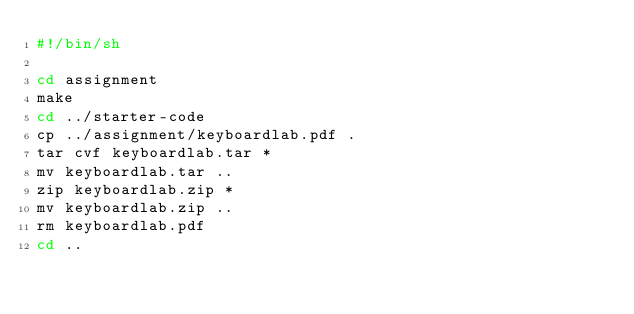Convert code to text. <code><loc_0><loc_0><loc_500><loc_500><_Bash_>#!/bin/sh

cd assignment
make
cd ../starter-code
cp ../assignment/keyboardlab.pdf .
tar cvf keyboardlab.tar *
mv keyboardlab.tar ..
zip keyboardlab.zip *
mv keyboardlab.zip ..
rm keyboardlab.pdf
cd ..

</code> 